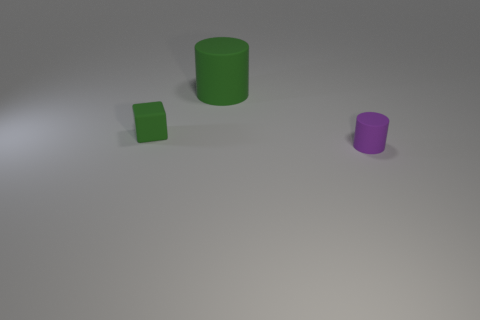Add 1 tiny matte cubes. How many objects exist? 4 Subtract all cylinders. How many objects are left? 1 Add 2 big matte cylinders. How many big matte cylinders are left? 3 Add 3 big purple matte balls. How many big purple matte balls exist? 3 Subtract 0 blue spheres. How many objects are left? 3 Subtract all big things. Subtract all tiny green matte things. How many objects are left? 1 